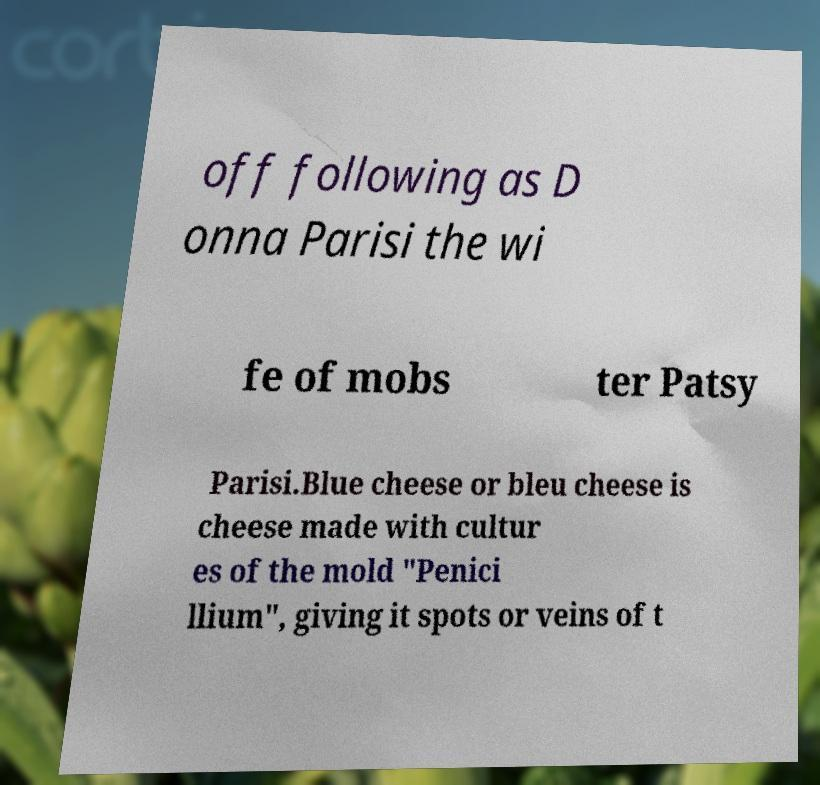What messages or text are displayed in this image? I need them in a readable, typed format. off following as D onna Parisi the wi fe of mobs ter Patsy Parisi.Blue cheese or bleu cheese is cheese made with cultur es of the mold "Penici llium", giving it spots or veins of t 